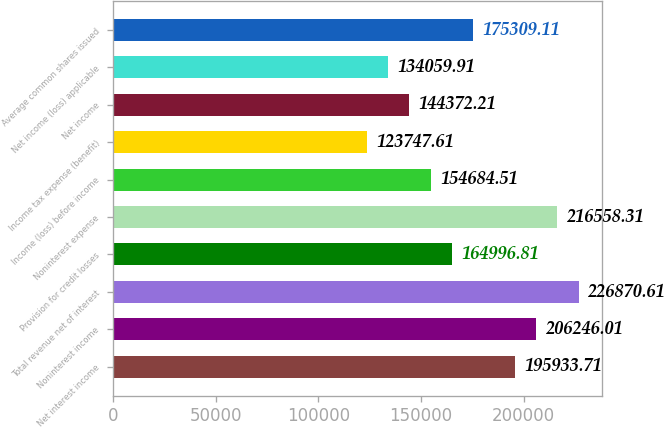Convert chart to OTSL. <chart><loc_0><loc_0><loc_500><loc_500><bar_chart><fcel>Net interest income<fcel>Noninterest income<fcel>Total revenue net of interest<fcel>Provision for credit losses<fcel>Noninterest expense<fcel>Income (loss) before income<fcel>Income tax expense (benefit)<fcel>Net income<fcel>Net income (loss) applicable<fcel>Average common shares issued<nl><fcel>195934<fcel>206246<fcel>226871<fcel>164997<fcel>216558<fcel>154685<fcel>123748<fcel>144372<fcel>134060<fcel>175309<nl></chart> 